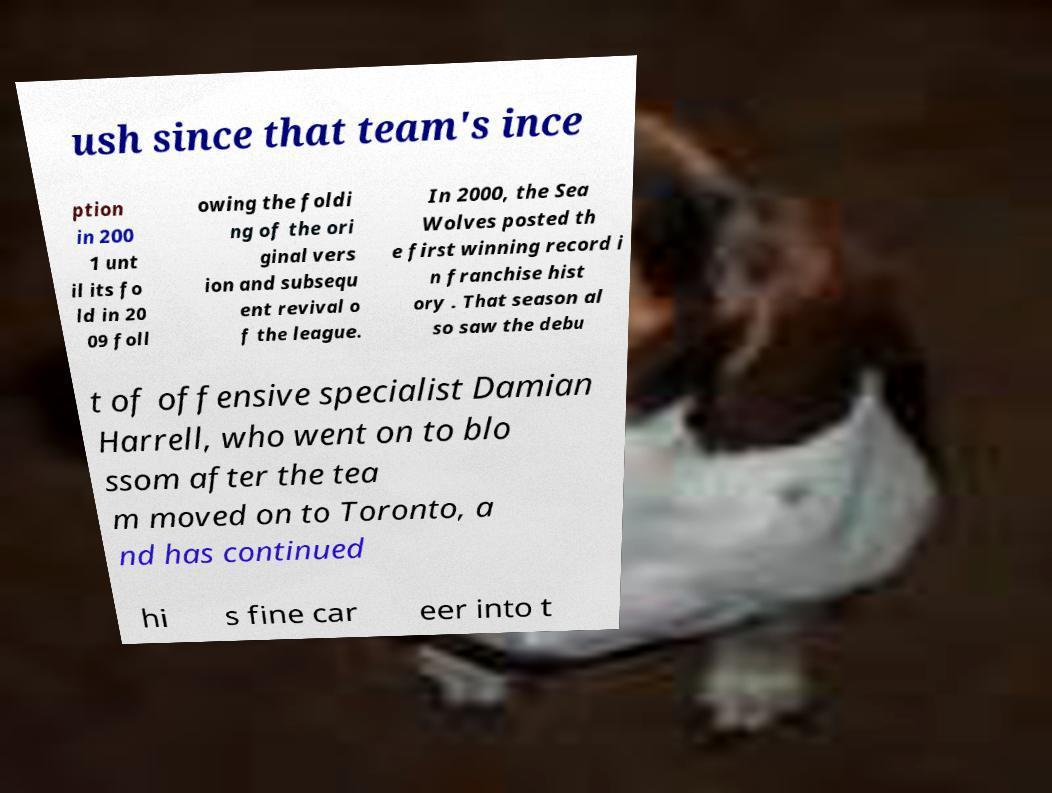I need the written content from this picture converted into text. Can you do that? ush since that team's ince ption in 200 1 unt il its fo ld in 20 09 foll owing the foldi ng of the ori ginal vers ion and subsequ ent revival o f the league. In 2000, the Sea Wolves posted th e first winning record i n franchise hist ory . That season al so saw the debu t of offensive specialist Damian Harrell, who went on to blo ssom after the tea m moved on to Toronto, a nd has continued hi s fine car eer into t 